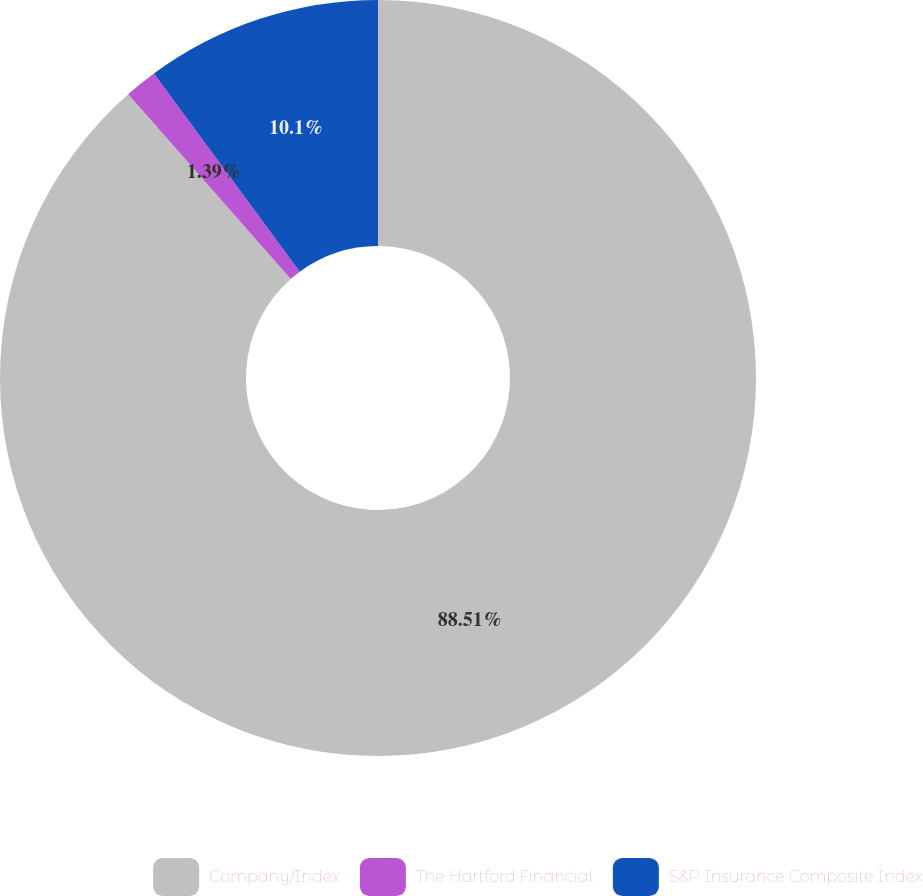Convert chart to OTSL. <chart><loc_0><loc_0><loc_500><loc_500><pie_chart><fcel>Company/Index<fcel>The Hartford Financial<fcel>S&P Insurance Composite Index<nl><fcel>88.51%<fcel>1.39%<fcel>10.1%<nl></chart> 